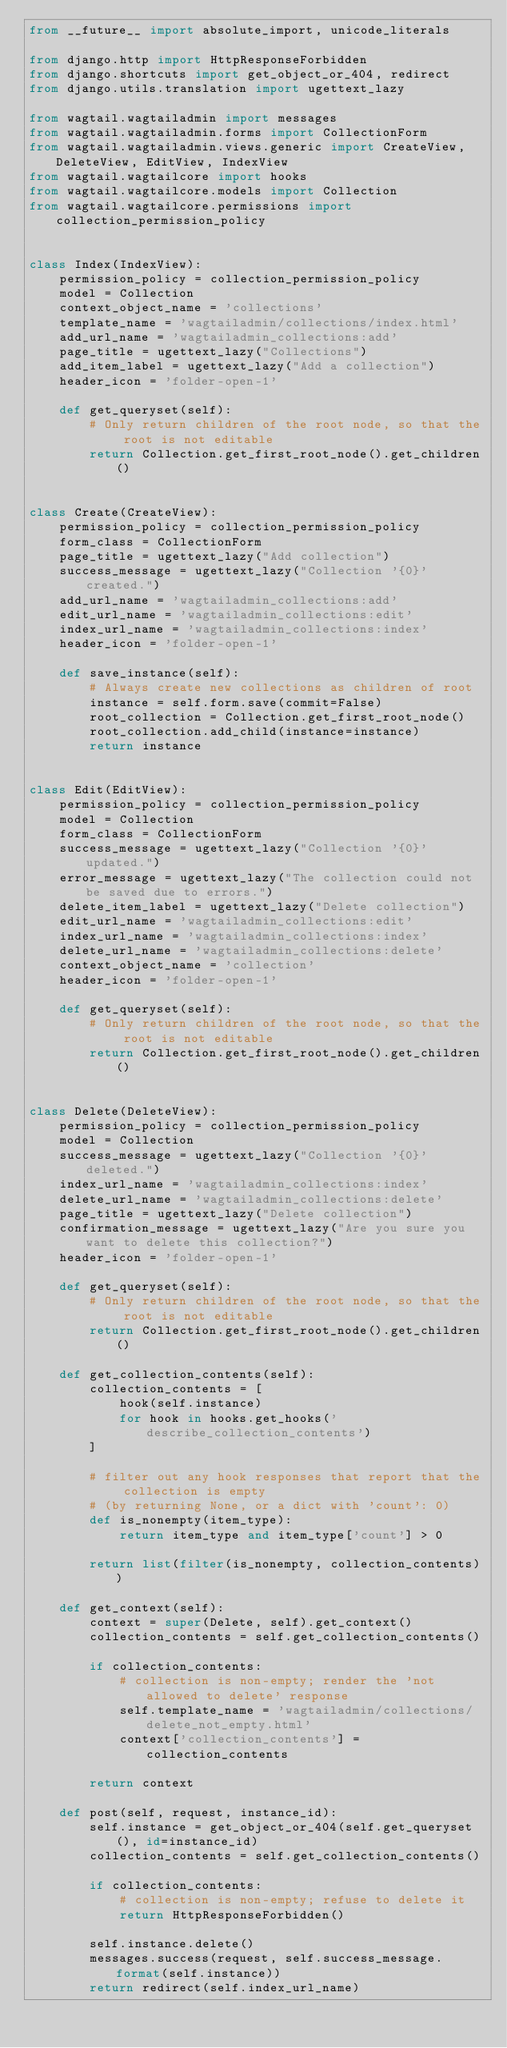Convert code to text. <code><loc_0><loc_0><loc_500><loc_500><_Python_>from __future__ import absolute_import, unicode_literals

from django.http import HttpResponseForbidden
from django.shortcuts import get_object_or_404, redirect
from django.utils.translation import ugettext_lazy

from wagtail.wagtailadmin import messages
from wagtail.wagtailadmin.forms import CollectionForm
from wagtail.wagtailadmin.views.generic import CreateView, DeleteView, EditView, IndexView
from wagtail.wagtailcore import hooks
from wagtail.wagtailcore.models import Collection
from wagtail.wagtailcore.permissions import collection_permission_policy


class Index(IndexView):
    permission_policy = collection_permission_policy
    model = Collection
    context_object_name = 'collections'
    template_name = 'wagtailadmin/collections/index.html'
    add_url_name = 'wagtailadmin_collections:add'
    page_title = ugettext_lazy("Collections")
    add_item_label = ugettext_lazy("Add a collection")
    header_icon = 'folder-open-1'

    def get_queryset(self):
        # Only return children of the root node, so that the root is not editable
        return Collection.get_first_root_node().get_children()


class Create(CreateView):
    permission_policy = collection_permission_policy
    form_class = CollectionForm
    page_title = ugettext_lazy("Add collection")
    success_message = ugettext_lazy("Collection '{0}' created.")
    add_url_name = 'wagtailadmin_collections:add'
    edit_url_name = 'wagtailadmin_collections:edit'
    index_url_name = 'wagtailadmin_collections:index'
    header_icon = 'folder-open-1'

    def save_instance(self):
        # Always create new collections as children of root
        instance = self.form.save(commit=False)
        root_collection = Collection.get_first_root_node()
        root_collection.add_child(instance=instance)
        return instance


class Edit(EditView):
    permission_policy = collection_permission_policy
    model = Collection
    form_class = CollectionForm
    success_message = ugettext_lazy("Collection '{0}' updated.")
    error_message = ugettext_lazy("The collection could not be saved due to errors.")
    delete_item_label = ugettext_lazy("Delete collection")
    edit_url_name = 'wagtailadmin_collections:edit'
    index_url_name = 'wagtailadmin_collections:index'
    delete_url_name = 'wagtailadmin_collections:delete'
    context_object_name = 'collection'
    header_icon = 'folder-open-1'

    def get_queryset(self):
        # Only return children of the root node, so that the root is not editable
        return Collection.get_first_root_node().get_children()


class Delete(DeleteView):
    permission_policy = collection_permission_policy
    model = Collection
    success_message = ugettext_lazy("Collection '{0}' deleted.")
    index_url_name = 'wagtailadmin_collections:index'
    delete_url_name = 'wagtailadmin_collections:delete'
    page_title = ugettext_lazy("Delete collection")
    confirmation_message = ugettext_lazy("Are you sure you want to delete this collection?")
    header_icon = 'folder-open-1'

    def get_queryset(self):
        # Only return children of the root node, so that the root is not editable
        return Collection.get_first_root_node().get_children()

    def get_collection_contents(self):
        collection_contents = [
            hook(self.instance)
            for hook in hooks.get_hooks('describe_collection_contents')
        ]

        # filter out any hook responses that report that the collection is empty
        # (by returning None, or a dict with 'count': 0)
        def is_nonempty(item_type):
            return item_type and item_type['count'] > 0

        return list(filter(is_nonempty, collection_contents))

    def get_context(self):
        context = super(Delete, self).get_context()
        collection_contents = self.get_collection_contents()

        if collection_contents:
            # collection is non-empty; render the 'not allowed to delete' response
            self.template_name = 'wagtailadmin/collections/delete_not_empty.html'
            context['collection_contents'] = collection_contents

        return context

    def post(self, request, instance_id):
        self.instance = get_object_or_404(self.get_queryset(), id=instance_id)
        collection_contents = self.get_collection_contents()

        if collection_contents:
            # collection is non-empty; refuse to delete it
            return HttpResponseForbidden()

        self.instance.delete()
        messages.success(request, self.success_message.format(self.instance))
        return redirect(self.index_url_name)
</code> 